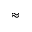Convert formula to latex. <formula><loc_0><loc_0><loc_500><loc_500>\approx</formula> 